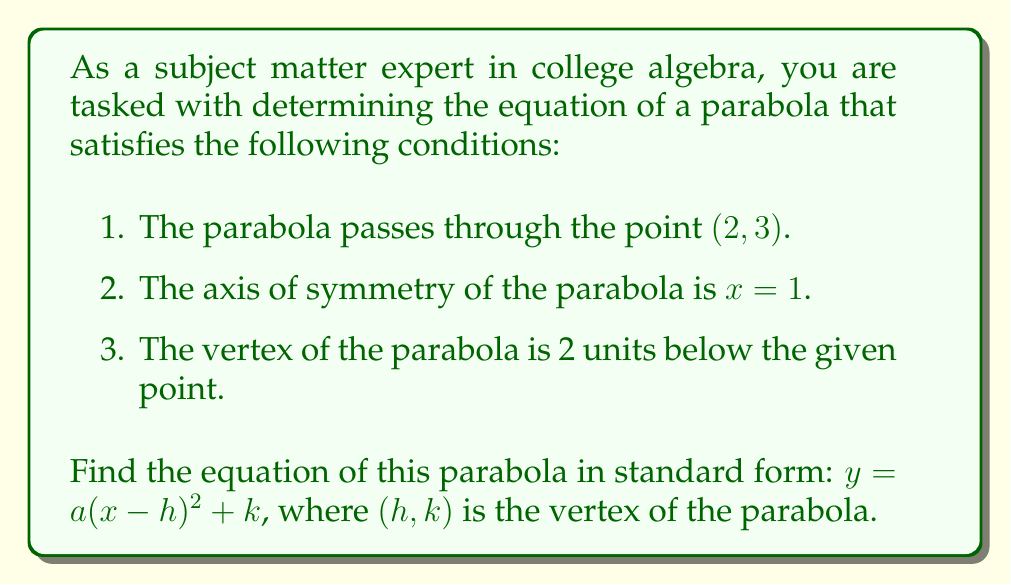What is the answer to this math problem? Let's approach this step-by-step:

1) We know that the axis of symmetry is $x = 1$, so the $h$ value in our equation will be 1.

2) We're told that the vertex is 2 units below the given point $(2, 3)$. Since the x-coordinate of the vertex is 1 (from the axis of symmetry), and it's 2 units below the point (2, 3), we can determine the y-coordinate of the vertex:

   $k = 3 - 2 = 1$

   So, the vertex is at $(1, 1)$.

3) Now we have the general form of our equation:

   $y = a(x - 1)^2 + 1$

4) To find $a$, we can use the given point $(2, 3)$. Substituting this into our equation:

   $3 = a(2 - 1)^2 + 1$
   $3 = a(1)^2 + 1$
   $3 = a + 1$
   $2 = a$

5) Therefore, $a = 2$, and our final equation is:

   $y = 2(x - 1)^2 + 1$

We can verify this by checking if it satisfies all conditions:
- It passes through $(2, 3)$: $3 = 2(2 - 1)^2 + 1 = 2(1)^2 + 1 = 2 + 1 = 3$ ✓
- The axis of symmetry is $x = 1$ ✓
- The vertex is at $(1, 1)$, which is 2 units below $(2, 3)$ ✓
Answer: $$y = 2(x - 1)^2 + 1$$ 